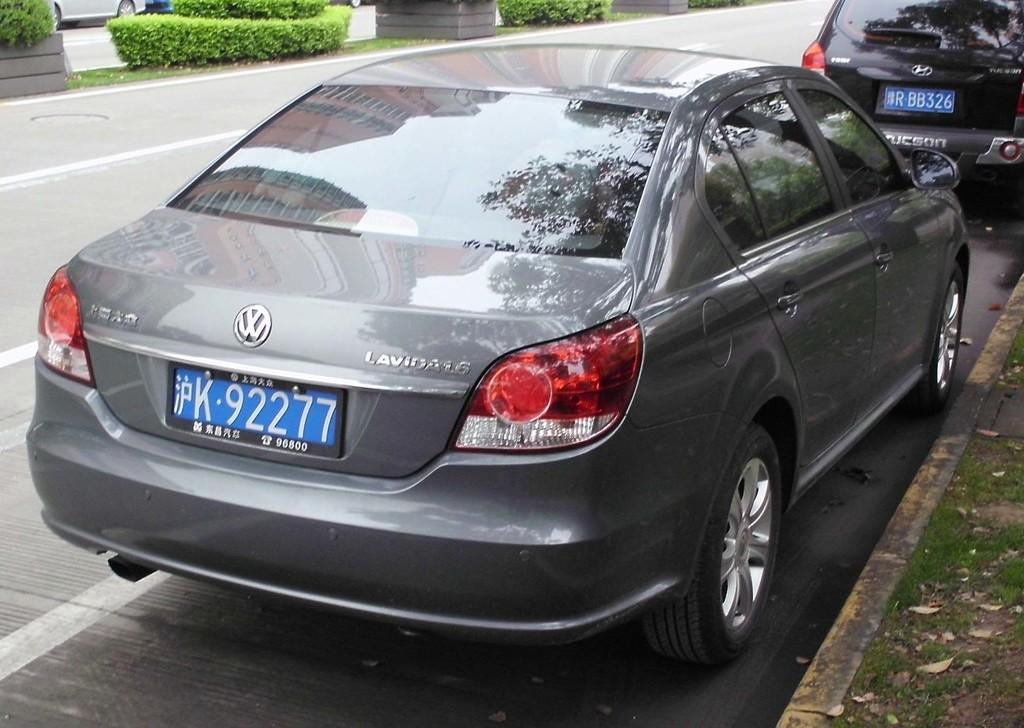<image>
Render a clear and concise summary of the photo. A Lavida model car is parked on the side of the road. 